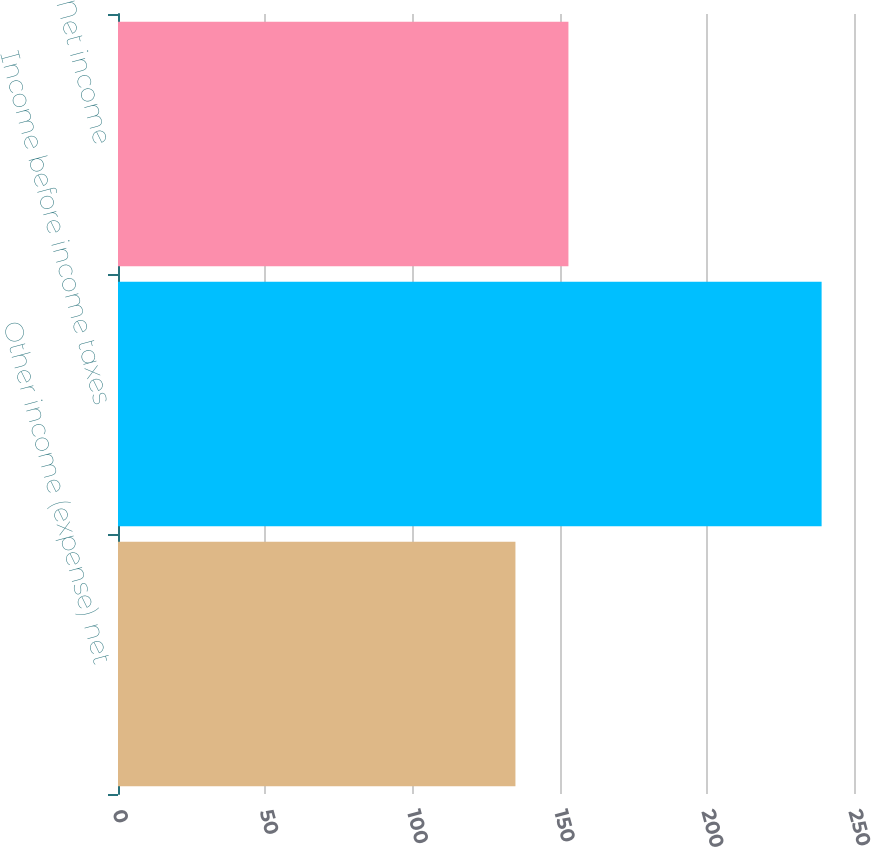Convert chart to OTSL. <chart><loc_0><loc_0><loc_500><loc_500><bar_chart><fcel>Other income (expense) net<fcel>Income before income taxes<fcel>Net income<nl><fcel>135<fcel>239<fcel>153<nl></chart> 